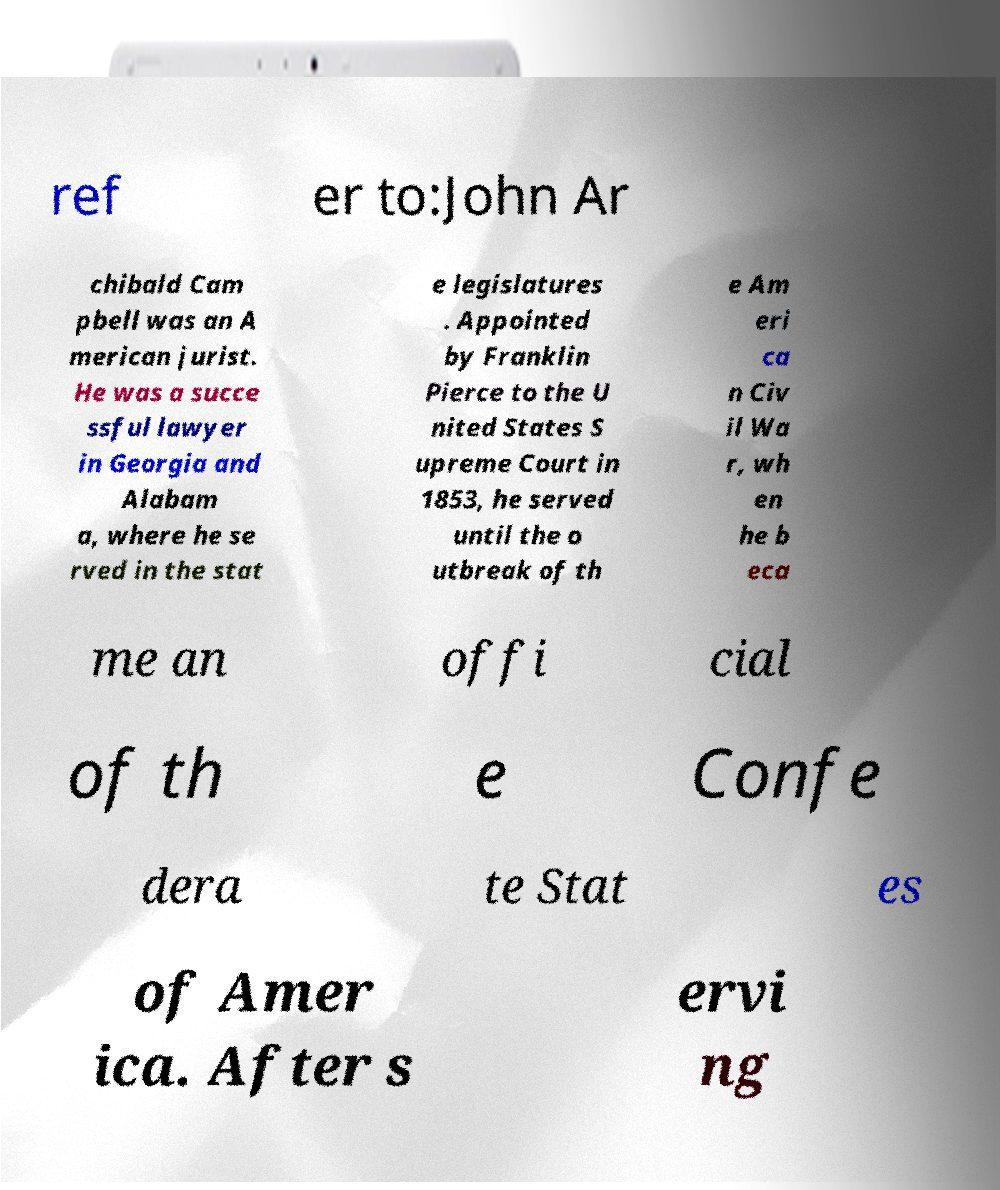There's text embedded in this image that I need extracted. Can you transcribe it verbatim? ref er to:John Ar chibald Cam pbell was an A merican jurist. He was a succe ssful lawyer in Georgia and Alabam a, where he se rved in the stat e legislatures . Appointed by Franklin Pierce to the U nited States S upreme Court in 1853, he served until the o utbreak of th e Am eri ca n Civ il Wa r, wh en he b eca me an offi cial of th e Confe dera te Stat es of Amer ica. After s ervi ng 